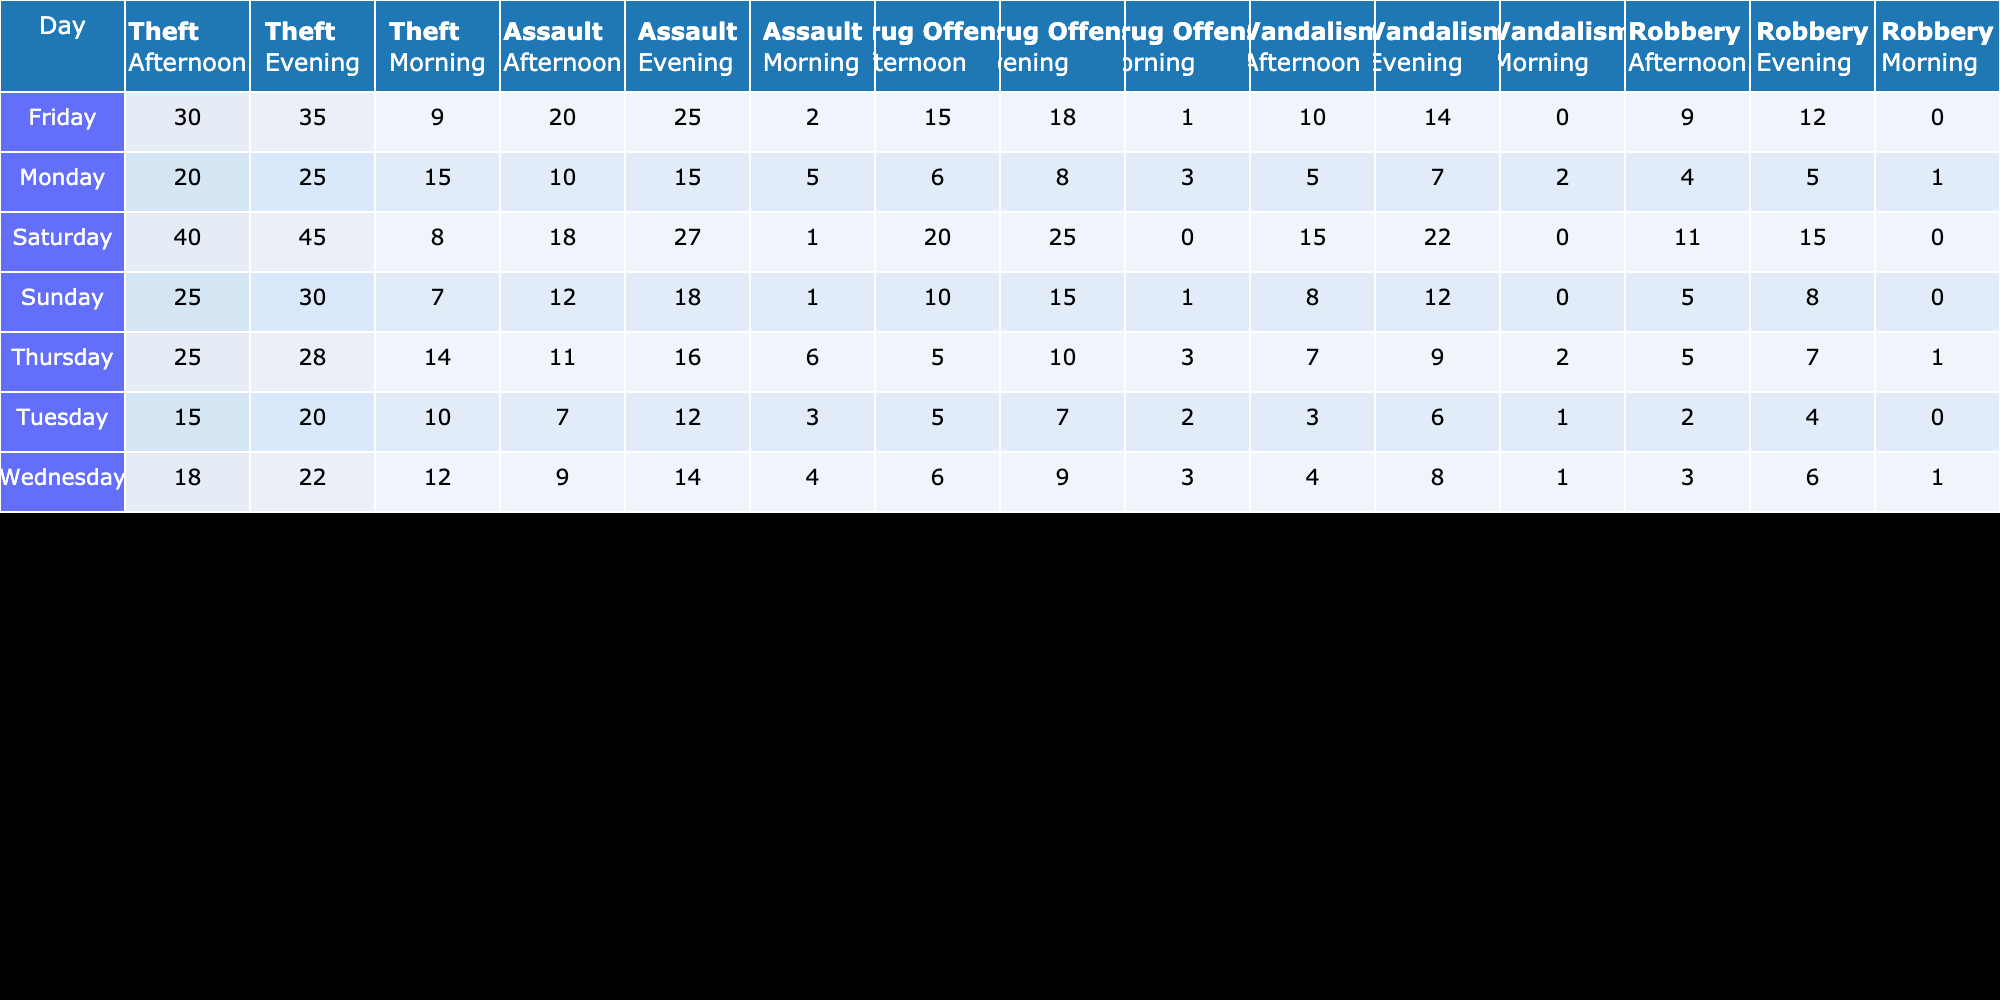What is the total number of thefts reported on Saturday? To find the total number of thefts on Saturday, I look at the "Theft" column for Saturday. It shows 8 for the morning, 40 for the afternoon, and 45 for the evening. Adding these values gives 8 + 40 + 45 = 93.
Answer: 93 Which time of day saw the highest number of assaults on Friday? On Friday, I check the "Assault" values at different times of the day. The morning has 2, the afternoon has 20, and the evening has 25. The highest number is from the evening with 25 assaults.
Answer: 25 On which day is the frequency of drug offenses the lowest? I review the "Drug Offense" column for all days. The values are: Monday 6, Tuesday 5, Wednesday 9, Thursday 10, Friday 18, Saturday 20, and Sunday 10. The lowest number is 2 on Tuesday morning.
Answer: Tuesday What is the average number of vandalism incidents reported during the weekends? I gather data for the weekends—Saturday has 0 (morning), 15 (afternoon), 22 (evening) and Sunday has 0 (morning), 8 (afternoon), 12 (evening). The total vandalism incidents are 0 + 15 + 22 + 0 + 8 + 12 = 57. There are 6 data points, so the average is 57 / 6 = 9.5.
Answer: 9.5 Is there a day with no reported robberies? I scan the "Robbery" column for all days to identify any zero values. I see values like 1 on Monday morning, 2 on Tuesday afternoon, and 0 on Tuesday morning, but not a complete day with zero. Hence, there are no days without reports.
Answer: No Which day and time has the maximum total of all types of crimes combined? To find this, I first calculate the total of all crimes for each day and time. For example, calculating Friday evening gives: Theft 35 + Assault 25 + Drug Offense 18 + Vandalism 14 + Robbery 12 = 104. Continuing this process, I find that Thursday evening totals 100, which is the largest.
Answer: Friday Evening What is the percentage increase in thefts from Monday evening to Friday evening? I find the thefts on Monday evening (25) and Friday evening (35). First, I calculate the difference: 35 - 25 = 10. Then, I find the percentage increase by dividing the difference by the Monday figure: (10 / 25) * 100 = 40%.
Answer: 40% What day has the most consistent reporting of thefts throughout the day (least variation)? I look at the "Theft" column across each day. For Saturday, the numbers are 8, 40, 45. The variation can be calculated but results in significant differences. Checking through all combinations, Tuesday shows low amounts: 10, 15, and 20, amounting to less variation.
Answer: Tuesday 